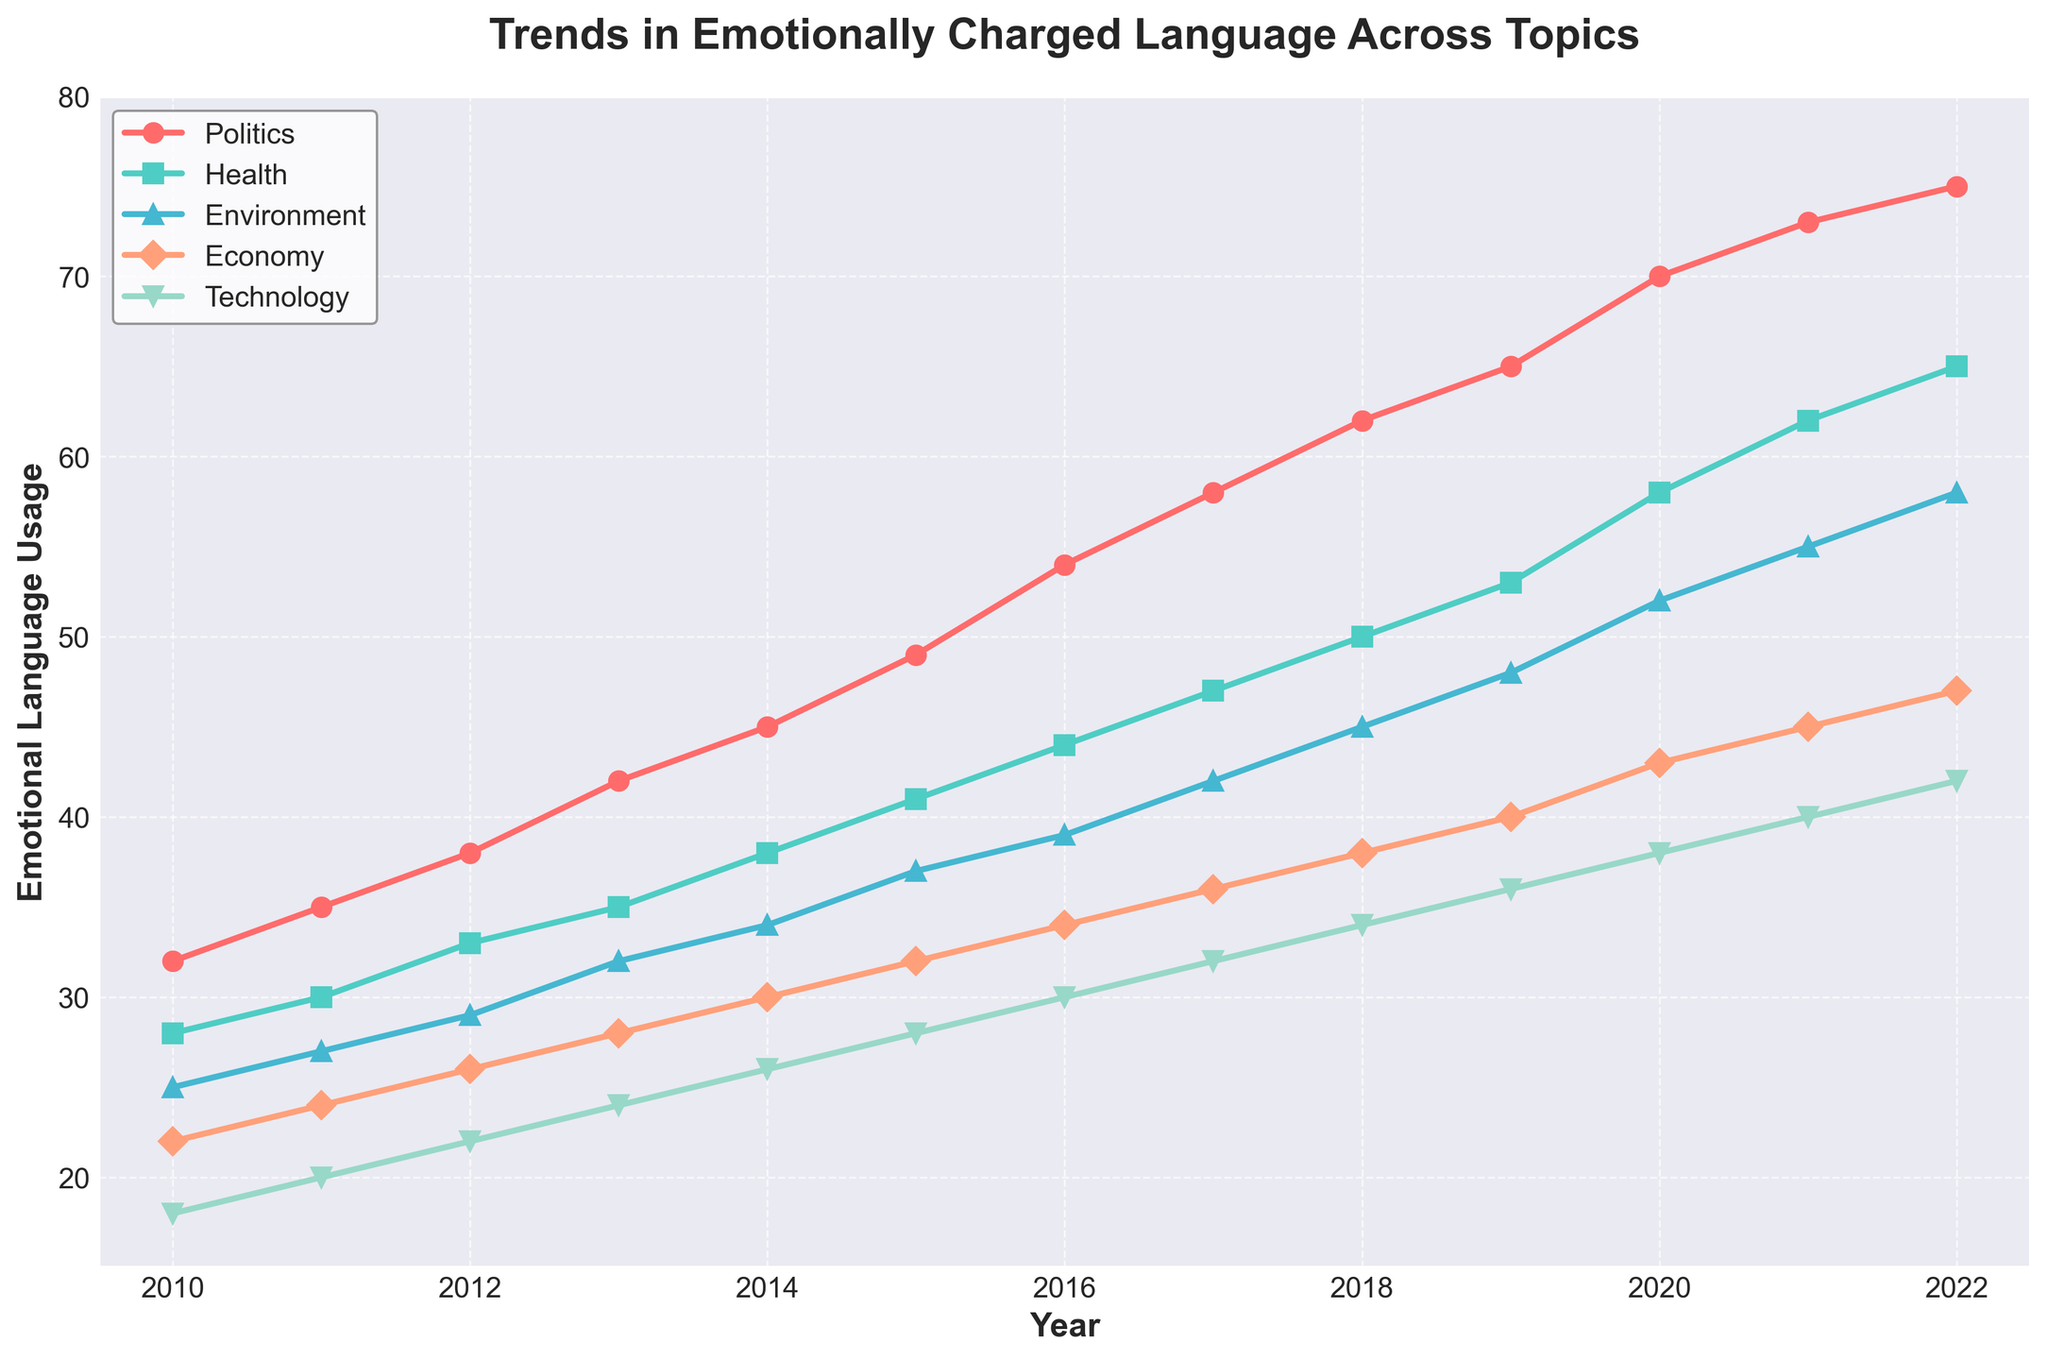What was the percentage increase in the use of emotionally charged language in news articles about Politics from 2010 to 2022? The value for Politics in 2010 is 32 and in 2022 is 75. The percentage increase is ((75 - 32) / 32) * 100. So, ((75 - 32) / 32) * 100 = (43 / 32) * 100 ≈ 134.38%
Answer: 134.38% What is the difference in emotionally charged language usage between the topics of Health and Environment in 2017? The value for Health in 2017 is 47 and for Environment in 2017 is 42, so the difference is 47 - 42 = 5
Answer: 5 Which topic had the highest increase in emotionally charged language usage from 2010 to 2022? By comparing the values in 2010 and 2022, we see Politics increased the most from 32 to 75, which is an increase of 43 units.
Answer: Politics In which year did Technology see a higher emotionally charged language usage than Economy? We look at the years where Technology's values are greater than those of Economy. In 2022, Technology has 42, while Economy has 47, so Technology did not surpass Economy in any year according to the given data.
Answer: Never What was the average emotionally charged language usage for the topic Health across the entire period? To find the average: (28 + 30 + 33 + 35 + 38 + 41 + 44 + 47 + 50 + 53 + 58 + 62 + 65) / 13. Summing these values: 28 + 30 + 33 + 35 + 38 + 41 + 44 + 47 + 50 + 53 + 58 + 62 + 65 = 584. Then, 584 / 13 ≈ 44.92
Answer: 44.92 How does the trend in the use of emotionally charged language in articles about the Environment compare to those about Technology from 2015 to 2022? From 2015 to 2022, Environment increased from 37 to 58 (21 units) while Technology increased from 28 to 42 (14 units). This makes Environment's increase 7 units larger than Technology's.
Answer: Environment increased more How many times did the use of emotionally charged language about Health surpass 50 units? Checking each year's values for Health: 2018 (50), 2019 (53), 2020 (58), 2021 (62), and 2022 (65). So 5 years in total.
Answer: 5 Which year saw the sharpest rise in Politics emotionally charged language usage? By examining year-on-year increases, the sharpest rise happens from 2016 to 2017 (54 to 58), which is an increase of 4 units. Comparing with significant increases: 2015 to 2016 (49 to 54 = 5 units), 2020 to 2021 shows an increase of 3 units (70 to 73). Hence, 2015 to 2016 has the highest increase.
Answer: 2015 to 2016 What is the combined use of emotionally charged language for all topics in 2020? The values for 2020 are Politics: 70, Health: 58, Environment: 52, Economy: 43, Technology: 38. Summing these values: 70 + 58 + 52 + 43 + 38 = 261
Answer: 261 